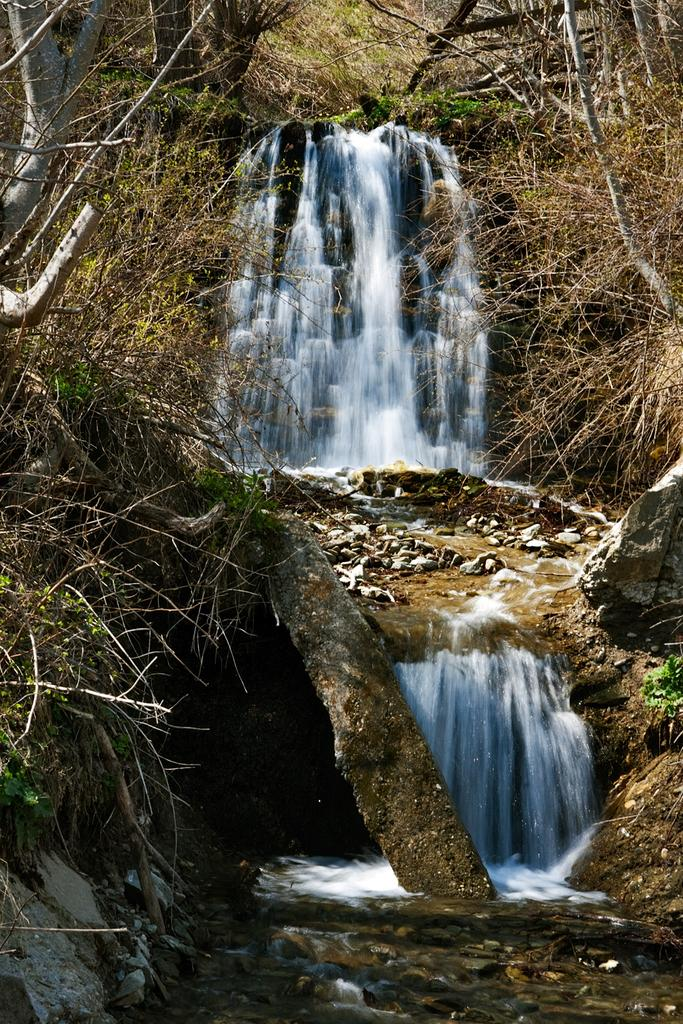What natural feature is the main subject of the image? There is a waterfall in the image. What type of vegetation can be seen in the image? There are dried grass and green grass in the image. What type of pencil is being used to draw the waterfall in the image? There is no pencil present in the image, as it is a photograph of a real waterfall. What type of locket can be seen hanging from the dried grass in the image? There is no locket present in the image; it features a waterfall and grass. 